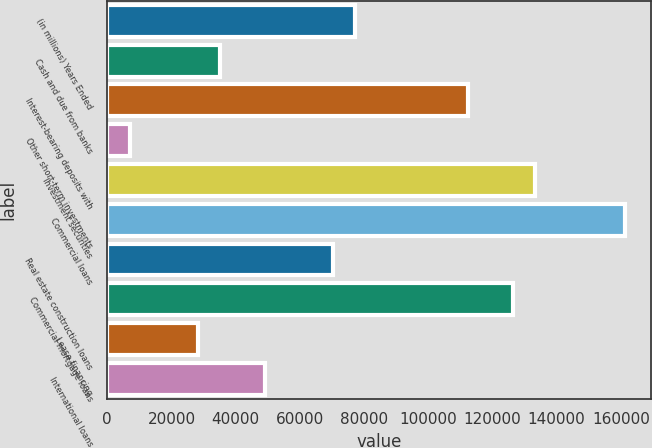Convert chart. <chart><loc_0><loc_0><loc_500><loc_500><bar_chart><fcel>(in millions) Years Ended<fcel>Cash and due from banks<fcel>Interest-bearing deposits with<fcel>Other short-term investments<fcel>Investment securities<fcel>Commercial loans<fcel>Real estate construction loans<fcel>Commercial mortgage loans<fcel>Lease financing<fcel>International loans<nl><fcel>77262.4<fcel>35170<fcel>112339<fcel>7108.4<fcel>133386<fcel>161447<fcel>70247<fcel>126370<fcel>28154.6<fcel>49200.8<nl></chart> 